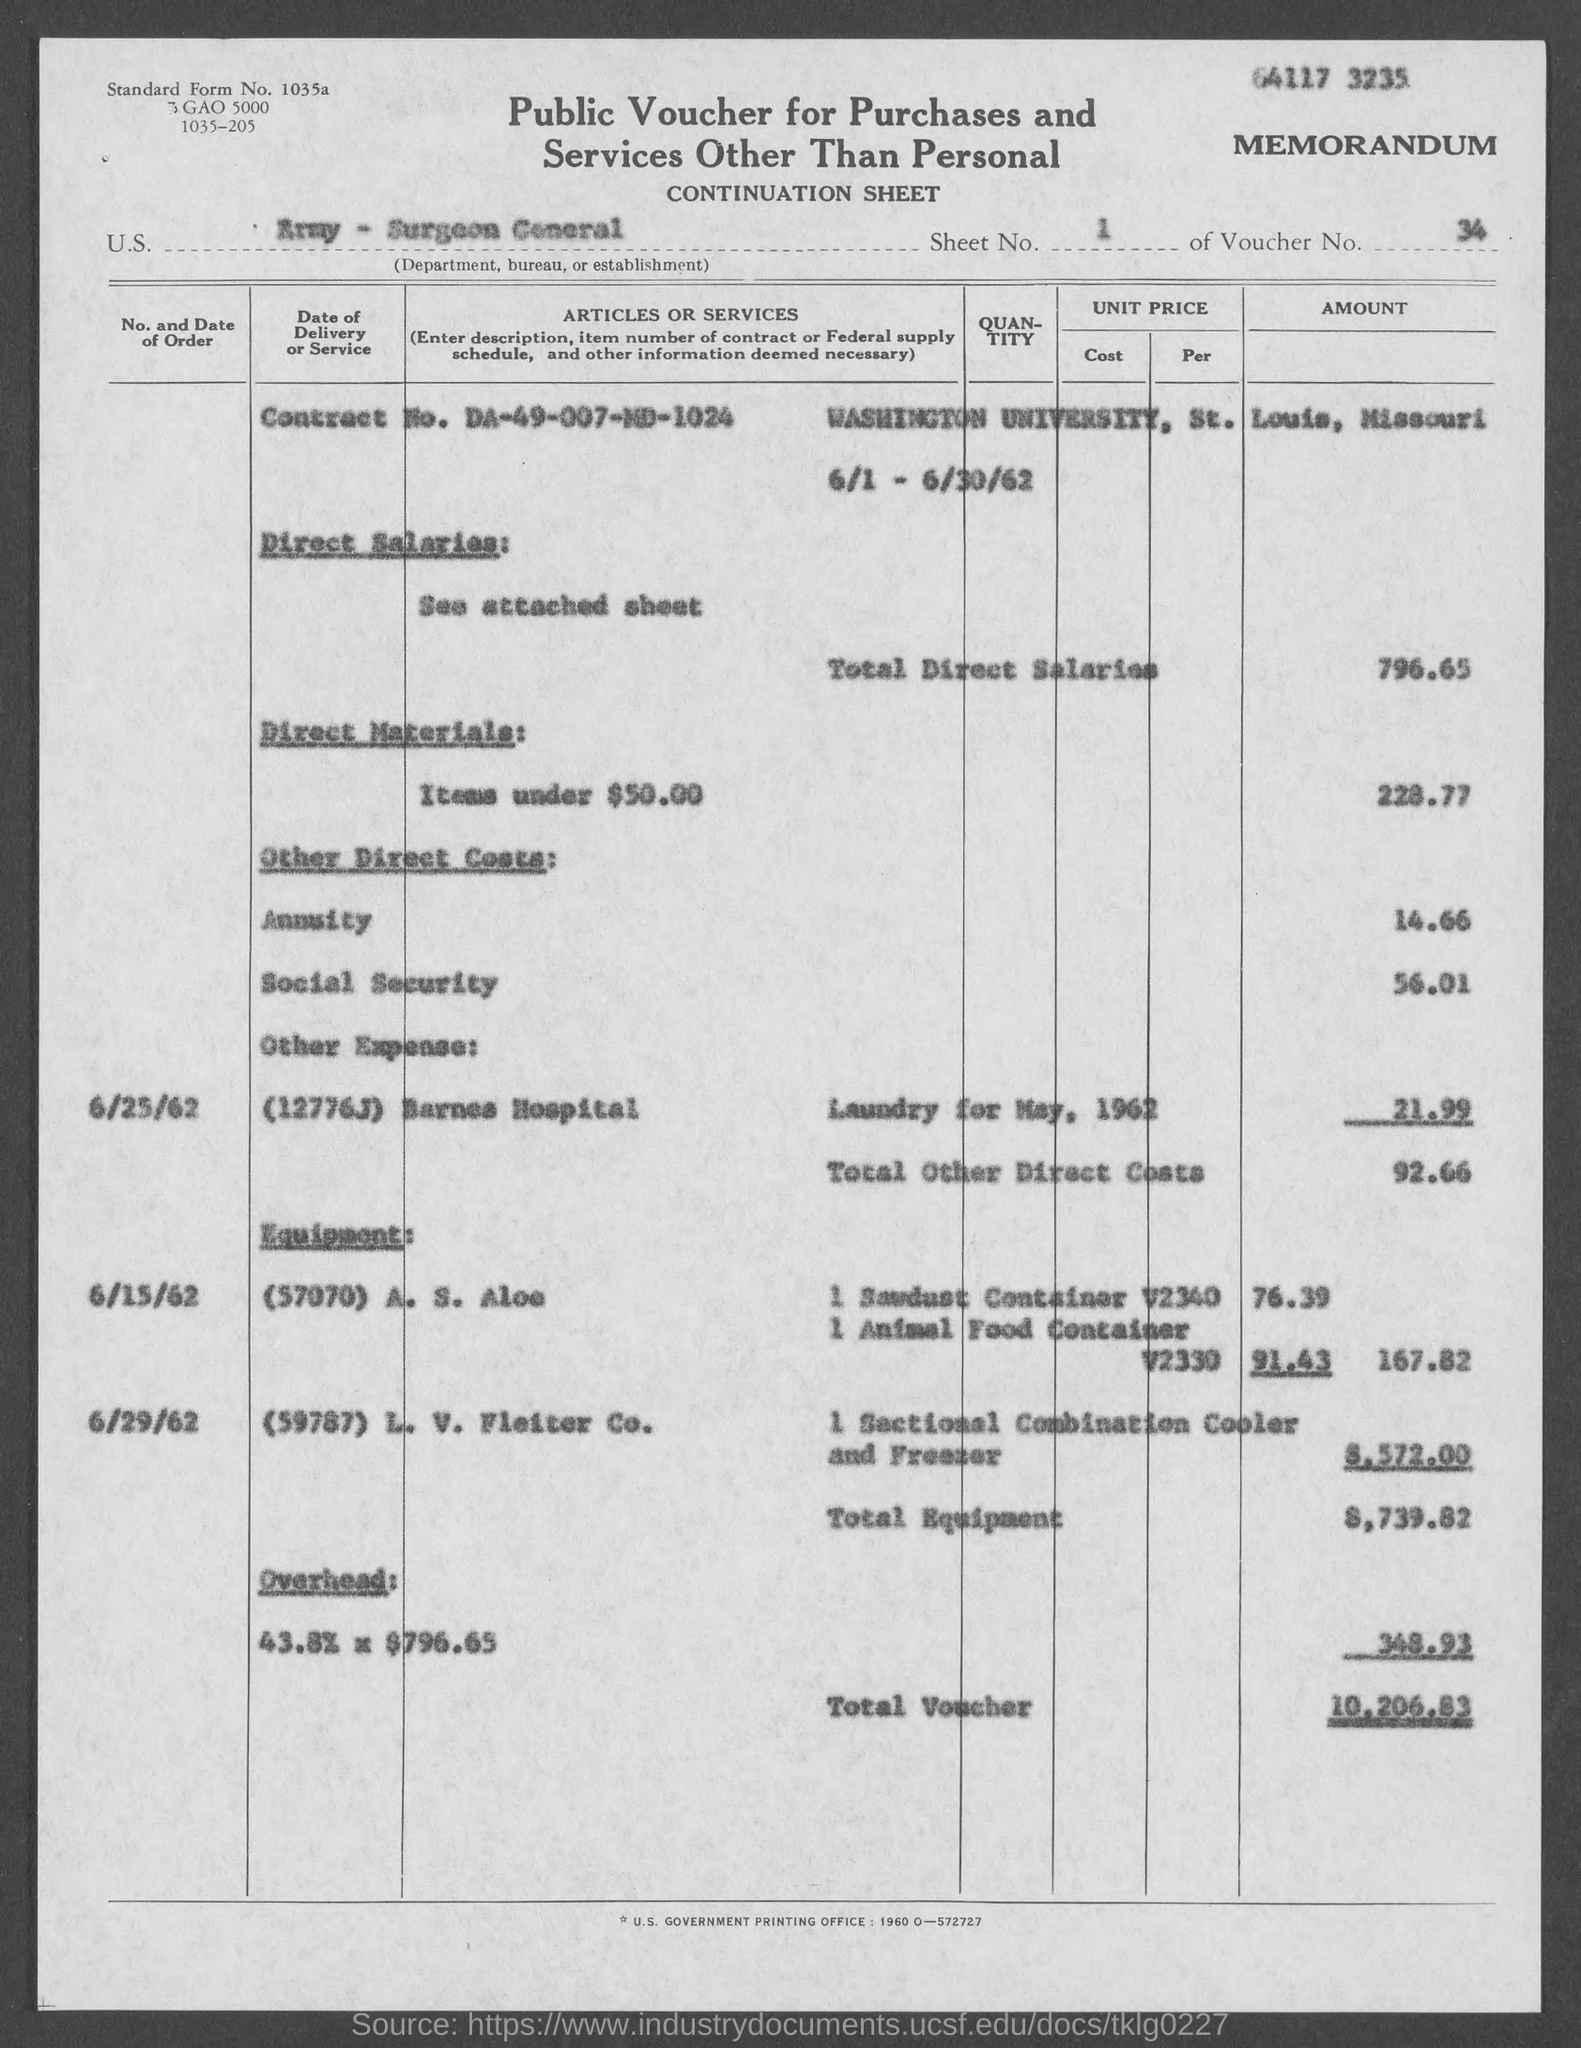Point out several critical features in this image. The total direct salaries are 796.65. The total voucher amount is $10,206.83. The voucher number is 34. The total other direct costs are 92.66... What is the contract number? DA-49-007-MD-1024... 